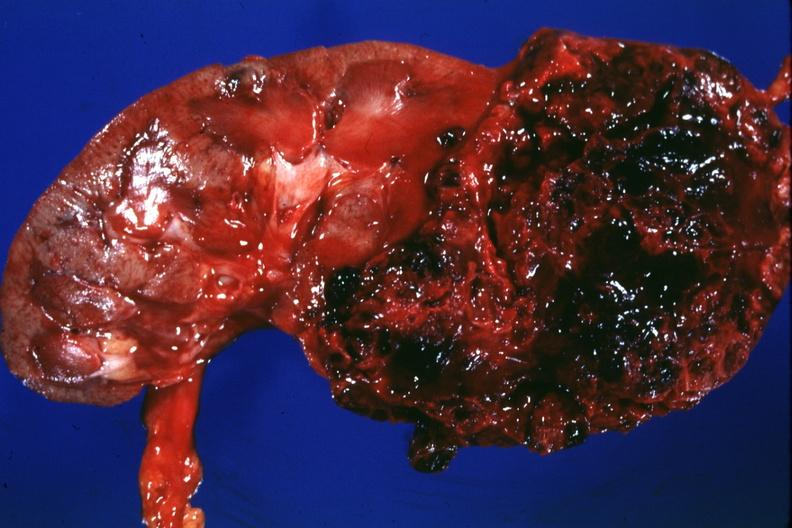s absence of palpebral fissure cleft palate present?
Answer the question using a single word or phrase. No 